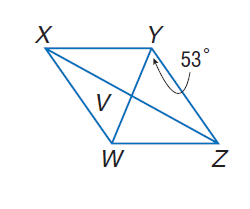Question: Use rhombus X Y Z W with m \angle W Y Z = 53, V W = 3, X V = 2 a - 2, and Z V = \frac { 5 a + 1 } { 4 }. Find X W.
Choices:
A. 5
B. 10
C. 15
D. 20
Answer with the letter. Answer: A Question: Use rhombus X Y Z W with m \angle W Y Z = 53, V W = 3, X V = 2 a - 2, and Z V = \frac { 5 a + 1 } { 4 }. Find X Z.
Choices:
A. 2
B. 4
C. 8
D. 16
Answer with the letter. Answer: C Question: Use rhombus X Y Z W with m \angle W Y Z = 53, V W = 3, X V = 2 a - 2, and Z V = \frac { 5 a + 1 } { 4 }. Find m \angle Y Z V.
Choices:
A. 18
B. 37
C. 53
D. 90
Answer with the letter. Answer: B Question: Use rhombus X Y Z W with m \angle W Y Z = 53, V W = 3, X V = 2 a - 2, and Z V = \frac { 5 a + 1 } { 4 }. Find m \angle X Y W.
Choices:
A. 18
B. 37
C. 53
D. 90
Answer with the letter. Answer: C 